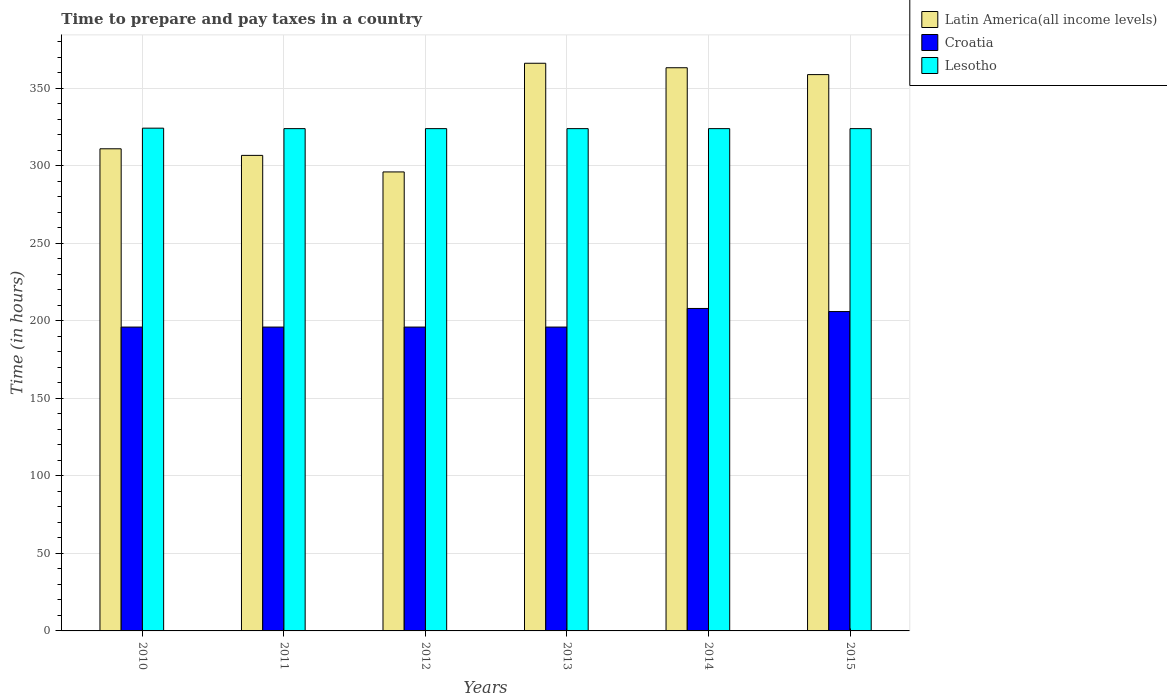How many different coloured bars are there?
Give a very brief answer. 3. How many groups of bars are there?
Offer a terse response. 6. Are the number of bars on each tick of the X-axis equal?
Keep it short and to the point. Yes. How many bars are there on the 4th tick from the right?
Offer a very short reply. 3. What is the label of the 3rd group of bars from the left?
Provide a short and direct response. 2012. In how many cases, is the number of bars for a given year not equal to the number of legend labels?
Offer a very short reply. 0. What is the number of hours required to prepare and pay taxes in Croatia in 2014?
Provide a succinct answer. 208. Across all years, what is the maximum number of hours required to prepare and pay taxes in Croatia?
Your answer should be very brief. 208. Across all years, what is the minimum number of hours required to prepare and pay taxes in Latin America(all income levels)?
Your answer should be compact. 296.06. In which year was the number of hours required to prepare and pay taxes in Latin America(all income levels) minimum?
Ensure brevity in your answer.  2012. What is the total number of hours required to prepare and pay taxes in Croatia in the graph?
Your response must be concise. 1198. What is the difference between the number of hours required to prepare and pay taxes in Lesotho in 2012 and that in 2015?
Your answer should be very brief. 0. What is the difference between the number of hours required to prepare and pay taxes in Latin America(all income levels) in 2010 and the number of hours required to prepare and pay taxes in Croatia in 2014?
Offer a very short reply. 103. What is the average number of hours required to prepare and pay taxes in Latin America(all income levels) per year?
Your answer should be compact. 333.68. In the year 2011, what is the difference between the number of hours required to prepare and pay taxes in Latin America(all income levels) and number of hours required to prepare and pay taxes in Lesotho?
Your response must be concise. -17.26. In how many years, is the number of hours required to prepare and pay taxes in Croatia greater than 60 hours?
Make the answer very short. 6. What is the ratio of the number of hours required to prepare and pay taxes in Lesotho in 2010 to that in 2015?
Give a very brief answer. 1. Is the number of hours required to prepare and pay taxes in Latin America(all income levels) in 2012 less than that in 2014?
Offer a very short reply. Yes. Is the difference between the number of hours required to prepare and pay taxes in Latin America(all income levels) in 2012 and 2013 greater than the difference between the number of hours required to prepare and pay taxes in Lesotho in 2012 and 2013?
Provide a short and direct response. No. What is the difference between the highest and the second highest number of hours required to prepare and pay taxes in Latin America(all income levels)?
Give a very brief answer. 2.89. What is the difference between the highest and the lowest number of hours required to prepare and pay taxes in Lesotho?
Offer a terse response. 0.3. In how many years, is the number of hours required to prepare and pay taxes in Lesotho greater than the average number of hours required to prepare and pay taxes in Lesotho taken over all years?
Your answer should be very brief. 1. What does the 2nd bar from the left in 2014 represents?
Your response must be concise. Croatia. What does the 3rd bar from the right in 2011 represents?
Your answer should be compact. Latin America(all income levels). How many bars are there?
Offer a very short reply. 18. Are all the bars in the graph horizontal?
Ensure brevity in your answer.  No. What is the difference between two consecutive major ticks on the Y-axis?
Your response must be concise. 50. Does the graph contain any zero values?
Provide a short and direct response. No. Does the graph contain grids?
Make the answer very short. Yes. Where does the legend appear in the graph?
Provide a short and direct response. Top right. How many legend labels are there?
Make the answer very short. 3. What is the title of the graph?
Your answer should be compact. Time to prepare and pay taxes in a country. What is the label or title of the Y-axis?
Offer a terse response. Time (in hours). What is the Time (in hours) in Latin America(all income levels) in 2010?
Provide a succinct answer. 311. What is the Time (in hours) of Croatia in 2010?
Your answer should be compact. 196. What is the Time (in hours) in Lesotho in 2010?
Provide a succinct answer. 324.3. What is the Time (in hours) of Latin America(all income levels) in 2011?
Provide a succinct answer. 306.74. What is the Time (in hours) of Croatia in 2011?
Make the answer very short. 196. What is the Time (in hours) in Lesotho in 2011?
Your answer should be compact. 324. What is the Time (in hours) in Latin America(all income levels) in 2012?
Make the answer very short. 296.06. What is the Time (in hours) in Croatia in 2012?
Provide a short and direct response. 196. What is the Time (in hours) of Lesotho in 2012?
Make the answer very short. 324. What is the Time (in hours) in Latin America(all income levels) in 2013?
Provide a short and direct response. 366.17. What is the Time (in hours) in Croatia in 2013?
Make the answer very short. 196. What is the Time (in hours) in Lesotho in 2013?
Provide a short and direct response. 324. What is the Time (in hours) of Latin America(all income levels) in 2014?
Offer a terse response. 363.27. What is the Time (in hours) of Croatia in 2014?
Provide a short and direct response. 208. What is the Time (in hours) of Lesotho in 2014?
Provide a short and direct response. 324. What is the Time (in hours) in Latin America(all income levels) in 2015?
Offer a very short reply. 358.85. What is the Time (in hours) of Croatia in 2015?
Provide a short and direct response. 206. What is the Time (in hours) in Lesotho in 2015?
Make the answer very short. 324. Across all years, what is the maximum Time (in hours) of Latin America(all income levels)?
Offer a very short reply. 366.17. Across all years, what is the maximum Time (in hours) in Croatia?
Make the answer very short. 208. Across all years, what is the maximum Time (in hours) in Lesotho?
Your response must be concise. 324.3. Across all years, what is the minimum Time (in hours) in Latin America(all income levels)?
Give a very brief answer. 296.06. Across all years, what is the minimum Time (in hours) of Croatia?
Offer a terse response. 196. Across all years, what is the minimum Time (in hours) of Lesotho?
Ensure brevity in your answer.  324. What is the total Time (in hours) in Latin America(all income levels) in the graph?
Ensure brevity in your answer.  2002.09. What is the total Time (in hours) of Croatia in the graph?
Your answer should be compact. 1198. What is the total Time (in hours) of Lesotho in the graph?
Offer a very short reply. 1944.3. What is the difference between the Time (in hours) of Latin America(all income levels) in 2010 and that in 2011?
Offer a terse response. 4.26. What is the difference between the Time (in hours) in Croatia in 2010 and that in 2011?
Give a very brief answer. 0. What is the difference between the Time (in hours) in Lesotho in 2010 and that in 2011?
Ensure brevity in your answer.  0.3. What is the difference between the Time (in hours) in Latin America(all income levels) in 2010 and that in 2012?
Keep it short and to the point. 14.94. What is the difference between the Time (in hours) of Croatia in 2010 and that in 2012?
Provide a short and direct response. 0. What is the difference between the Time (in hours) of Latin America(all income levels) in 2010 and that in 2013?
Give a very brief answer. -55.17. What is the difference between the Time (in hours) of Croatia in 2010 and that in 2013?
Ensure brevity in your answer.  0. What is the difference between the Time (in hours) of Lesotho in 2010 and that in 2013?
Give a very brief answer. 0.3. What is the difference between the Time (in hours) of Latin America(all income levels) in 2010 and that in 2014?
Offer a terse response. -52.27. What is the difference between the Time (in hours) in Croatia in 2010 and that in 2014?
Give a very brief answer. -12. What is the difference between the Time (in hours) of Latin America(all income levels) in 2010 and that in 2015?
Ensure brevity in your answer.  -47.85. What is the difference between the Time (in hours) in Croatia in 2010 and that in 2015?
Provide a succinct answer. -10. What is the difference between the Time (in hours) in Lesotho in 2010 and that in 2015?
Keep it short and to the point. 0.3. What is the difference between the Time (in hours) of Latin America(all income levels) in 2011 and that in 2012?
Your answer should be compact. 10.68. What is the difference between the Time (in hours) of Lesotho in 2011 and that in 2012?
Provide a succinct answer. 0. What is the difference between the Time (in hours) of Latin America(all income levels) in 2011 and that in 2013?
Give a very brief answer. -59.42. What is the difference between the Time (in hours) of Croatia in 2011 and that in 2013?
Your answer should be compact. 0. What is the difference between the Time (in hours) in Lesotho in 2011 and that in 2013?
Keep it short and to the point. 0. What is the difference between the Time (in hours) in Latin America(all income levels) in 2011 and that in 2014?
Provide a succinct answer. -56.53. What is the difference between the Time (in hours) of Croatia in 2011 and that in 2014?
Make the answer very short. -12. What is the difference between the Time (in hours) of Latin America(all income levels) in 2011 and that in 2015?
Offer a very short reply. -52.11. What is the difference between the Time (in hours) of Croatia in 2011 and that in 2015?
Your response must be concise. -10. What is the difference between the Time (in hours) of Latin America(all income levels) in 2012 and that in 2013?
Provide a succinct answer. -70.1. What is the difference between the Time (in hours) in Croatia in 2012 and that in 2013?
Your answer should be very brief. 0. What is the difference between the Time (in hours) in Lesotho in 2012 and that in 2013?
Keep it short and to the point. 0. What is the difference between the Time (in hours) of Latin America(all income levels) in 2012 and that in 2014?
Make the answer very short. -67.21. What is the difference between the Time (in hours) of Croatia in 2012 and that in 2014?
Ensure brevity in your answer.  -12. What is the difference between the Time (in hours) in Lesotho in 2012 and that in 2014?
Your answer should be very brief. 0. What is the difference between the Time (in hours) in Latin America(all income levels) in 2012 and that in 2015?
Provide a succinct answer. -62.78. What is the difference between the Time (in hours) in Croatia in 2012 and that in 2015?
Provide a short and direct response. -10. What is the difference between the Time (in hours) of Latin America(all income levels) in 2013 and that in 2014?
Provide a succinct answer. 2.89. What is the difference between the Time (in hours) of Lesotho in 2013 and that in 2014?
Provide a short and direct response. 0. What is the difference between the Time (in hours) of Latin America(all income levels) in 2013 and that in 2015?
Your answer should be very brief. 7.32. What is the difference between the Time (in hours) in Lesotho in 2013 and that in 2015?
Ensure brevity in your answer.  0. What is the difference between the Time (in hours) in Latin America(all income levels) in 2014 and that in 2015?
Your response must be concise. 4.42. What is the difference between the Time (in hours) of Croatia in 2014 and that in 2015?
Provide a short and direct response. 2. What is the difference between the Time (in hours) in Lesotho in 2014 and that in 2015?
Your answer should be compact. 0. What is the difference between the Time (in hours) of Latin America(all income levels) in 2010 and the Time (in hours) of Croatia in 2011?
Give a very brief answer. 115. What is the difference between the Time (in hours) of Croatia in 2010 and the Time (in hours) of Lesotho in 2011?
Offer a terse response. -128. What is the difference between the Time (in hours) of Latin America(all income levels) in 2010 and the Time (in hours) of Croatia in 2012?
Provide a short and direct response. 115. What is the difference between the Time (in hours) of Croatia in 2010 and the Time (in hours) of Lesotho in 2012?
Make the answer very short. -128. What is the difference between the Time (in hours) of Latin America(all income levels) in 2010 and the Time (in hours) of Croatia in 2013?
Offer a terse response. 115. What is the difference between the Time (in hours) in Croatia in 2010 and the Time (in hours) in Lesotho in 2013?
Provide a short and direct response. -128. What is the difference between the Time (in hours) in Latin America(all income levels) in 2010 and the Time (in hours) in Croatia in 2014?
Make the answer very short. 103. What is the difference between the Time (in hours) in Croatia in 2010 and the Time (in hours) in Lesotho in 2014?
Keep it short and to the point. -128. What is the difference between the Time (in hours) in Latin America(all income levels) in 2010 and the Time (in hours) in Croatia in 2015?
Keep it short and to the point. 105. What is the difference between the Time (in hours) in Latin America(all income levels) in 2010 and the Time (in hours) in Lesotho in 2015?
Provide a short and direct response. -13. What is the difference between the Time (in hours) in Croatia in 2010 and the Time (in hours) in Lesotho in 2015?
Keep it short and to the point. -128. What is the difference between the Time (in hours) of Latin America(all income levels) in 2011 and the Time (in hours) of Croatia in 2012?
Keep it short and to the point. 110.74. What is the difference between the Time (in hours) of Latin America(all income levels) in 2011 and the Time (in hours) of Lesotho in 2012?
Offer a very short reply. -17.26. What is the difference between the Time (in hours) in Croatia in 2011 and the Time (in hours) in Lesotho in 2012?
Your answer should be very brief. -128. What is the difference between the Time (in hours) in Latin America(all income levels) in 2011 and the Time (in hours) in Croatia in 2013?
Offer a very short reply. 110.74. What is the difference between the Time (in hours) of Latin America(all income levels) in 2011 and the Time (in hours) of Lesotho in 2013?
Your answer should be compact. -17.26. What is the difference between the Time (in hours) of Croatia in 2011 and the Time (in hours) of Lesotho in 2013?
Your answer should be very brief. -128. What is the difference between the Time (in hours) in Latin America(all income levels) in 2011 and the Time (in hours) in Croatia in 2014?
Provide a succinct answer. 98.74. What is the difference between the Time (in hours) of Latin America(all income levels) in 2011 and the Time (in hours) of Lesotho in 2014?
Your answer should be very brief. -17.26. What is the difference between the Time (in hours) of Croatia in 2011 and the Time (in hours) of Lesotho in 2014?
Ensure brevity in your answer.  -128. What is the difference between the Time (in hours) in Latin America(all income levels) in 2011 and the Time (in hours) in Croatia in 2015?
Make the answer very short. 100.74. What is the difference between the Time (in hours) of Latin America(all income levels) in 2011 and the Time (in hours) of Lesotho in 2015?
Provide a short and direct response. -17.26. What is the difference between the Time (in hours) of Croatia in 2011 and the Time (in hours) of Lesotho in 2015?
Provide a short and direct response. -128. What is the difference between the Time (in hours) of Latin America(all income levels) in 2012 and the Time (in hours) of Croatia in 2013?
Offer a terse response. 100.06. What is the difference between the Time (in hours) of Latin America(all income levels) in 2012 and the Time (in hours) of Lesotho in 2013?
Provide a succinct answer. -27.94. What is the difference between the Time (in hours) of Croatia in 2012 and the Time (in hours) of Lesotho in 2013?
Offer a very short reply. -128. What is the difference between the Time (in hours) of Latin America(all income levels) in 2012 and the Time (in hours) of Croatia in 2014?
Your response must be concise. 88.06. What is the difference between the Time (in hours) in Latin America(all income levels) in 2012 and the Time (in hours) in Lesotho in 2014?
Your answer should be compact. -27.94. What is the difference between the Time (in hours) of Croatia in 2012 and the Time (in hours) of Lesotho in 2014?
Ensure brevity in your answer.  -128. What is the difference between the Time (in hours) in Latin America(all income levels) in 2012 and the Time (in hours) in Croatia in 2015?
Give a very brief answer. 90.06. What is the difference between the Time (in hours) of Latin America(all income levels) in 2012 and the Time (in hours) of Lesotho in 2015?
Offer a very short reply. -27.94. What is the difference between the Time (in hours) of Croatia in 2012 and the Time (in hours) of Lesotho in 2015?
Offer a very short reply. -128. What is the difference between the Time (in hours) in Latin America(all income levels) in 2013 and the Time (in hours) in Croatia in 2014?
Keep it short and to the point. 158.17. What is the difference between the Time (in hours) in Latin America(all income levels) in 2013 and the Time (in hours) in Lesotho in 2014?
Your response must be concise. 42.17. What is the difference between the Time (in hours) of Croatia in 2013 and the Time (in hours) of Lesotho in 2014?
Provide a succinct answer. -128. What is the difference between the Time (in hours) of Latin America(all income levels) in 2013 and the Time (in hours) of Croatia in 2015?
Your response must be concise. 160.17. What is the difference between the Time (in hours) of Latin America(all income levels) in 2013 and the Time (in hours) of Lesotho in 2015?
Ensure brevity in your answer.  42.17. What is the difference between the Time (in hours) of Croatia in 2013 and the Time (in hours) of Lesotho in 2015?
Provide a succinct answer. -128. What is the difference between the Time (in hours) of Latin America(all income levels) in 2014 and the Time (in hours) of Croatia in 2015?
Offer a terse response. 157.27. What is the difference between the Time (in hours) of Latin America(all income levels) in 2014 and the Time (in hours) of Lesotho in 2015?
Give a very brief answer. 39.27. What is the difference between the Time (in hours) in Croatia in 2014 and the Time (in hours) in Lesotho in 2015?
Offer a terse response. -116. What is the average Time (in hours) of Latin America(all income levels) per year?
Your answer should be very brief. 333.68. What is the average Time (in hours) of Croatia per year?
Your answer should be very brief. 199.67. What is the average Time (in hours) in Lesotho per year?
Give a very brief answer. 324.05. In the year 2010, what is the difference between the Time (in hours) of Latin America(all income levels) and Time (in hours) of Croatia?
Ensure brevity in your answer.  115. In the year 2010, what is the difference between the Time (in hours) in Croatia and Time (in hours) in Lesotho?
Provide a short and direct response. -128.3. In the year 2011, what is the difference between the Time (in hours) in Latin America(all income levels) and Time (in hours) in Croatia?
Keep it short and to the point. 110.74. In the year 2011, what is the difference between the Time (in hours) of Latin America(all income levels) and Time (in hours) of Lesotho?
Give a very brief answer. -17.26. In the year 2011, what is the difference between the Time (in hours) in Croatia and Time (in hours) in Lesotho?
Offer a very short reply. -128. In the year 2012, what is the difference between the Time (in hours) in Latin America(all income levels) and Time (in hours) in Croatia?
Provide a short and direct response. 100.06. In the year 2012, what is the difference between the Time (in hours) in Latin America(all income levels) and Time (in hours) in Lesotho?
Provide a short and direct response. -27.94. In the year 2012, what is the difference between the Time (in hours) of Croatia and Time (in hours) of Lesotho?
Your response must be concise. -128. In the year 2013, what is the difference between the Time (in hours) of Latin America(all income levels) and Time (in hours) of Croatia?
Your answer should be very brief. 170.17. In the year 2013, what is the difference between the Time (in hours) in Latin America(all income levels) and Time (in hours) in Lesotho?
Your answer should be compact. 42.17. In the year 2013, what is the difference between the Time (in hours) in Croatia and Time (in hours) in Lesotho?
Provide a succinct answer. -128. In the year 2014, what is the difference between the Time (in hours) of Latin America(all income levels) and Time (in hours) of Croatia?
Provide a succinct answer. 155.27. In the year 2014, what is the difference between the Time (in hours) of Latin America(all income levels) and Time (in hours) of Lesotho?
Your answer should be compact. 39.27. In the year 2014, what is the difference between the Time (in hours) in Croatia and Time (in hours) in Lesotho?
Your response must be concise. -116. In the year 2015, what is the difference between the Time (in hours) in Latin America(all income levels) and Time (in hours) in Croatia?
Keep it short and to the point. 152.85. In the year 2015, what is the difference between the Time (in hours) of Latin America(all income levels) and Time (in hours) of Lesotho?
Make the answer very short. 34.85. In the year 2015, what is the difference between the Time (in hours) in Croatia and Time (in hours) in Lesotho?
Your answer should be very brief. -118. What is the ratio of the Time (in hours) in Latin America(all income levels) in 2010 to that in 2011?
Offer a very short reply. 1.01. What is the ratio of the Time (in hours) of Latin America(all income levels) in 2010 to that in 2012?
Make the answer very short. 1.05. What is the ratio of the Time (in hours) in Latin America(all income levels) in 2010 to that in 2013?
Provide a short and direct response. 0.85. What is the ratio of the Time (in hours) in Lesotho in 2010 to that in 2013?
Offer a terse response. 1. What is the ratio of the Time (in hours) of Latin America(all income levels) in 2010 to that in 2014?
Provide a succinct answer. 0.86. What is the ratio of the Time (in hours) in Croatia in 2010 to that in 2014?
Your answer should be compact. 0.94. What is the ratio of the Time (in hours) of Lesotho in 2010 to that in 2014?
Give a very brief answer. 1. What is the ratio of the Time (in hours) of Latin America(all income levels) in 2010 to that in 2015?
Offer a very short reply. 0.87. What is the ratio of the Time (in hours) of Croatia in 2010 to that in 2015?
Keep it short and to the point. 0.95. What is the ratio of the Time (in hours) of Lesotho in 2010 to that in 2015?
Your answer should be compact. 1. What is the ratio of the Time (in hours) of Latin America(all income levels) in 2011 to that in 2012?
Keep it short and to the point. 1.04. What is the ratio of the Time (in hours) in Lesotho in 2011 to that in 2012?
Your response must be concise. 1. What is the ratio of the Time (in hours) of Latin America(all income levels) in 2011 to that in 2013?
Give a very brief answer. 0.84. What is the ratio of the Time (in hours) of Croatia in 2011 to that in 2013?
Your answer should be very brief. 1. What is the ratio of the Time (in hours) in Lesotho in 2011 to that in 2013?
Offer a very short reply. 1. What is the ratio of the Time (in hours) in Latin America(all income levels) in 2011 to that in 2014?
Offer a very short reply. 0.84. What is the ratio of the Time (in hours) of Croatia in 2011 to that in 2014?
Offer a very short reply. 0.94. What is the ratio of the Time (in hours) in Lesotho in 2011 to that in 2014?
Your answer should be very brief. 1. What is the ratio of the Time (in hours) in Latin America(all income levels) in 2011 to that in 2015?
Your response must be concise. 0.85. What is the ratio of the Time (in hours) of Croatia in 2011 to that in 2015?
Make the answer very short. 0.95. What is the ratio of the Time (in hours) in Latin America(all income levels) in 2012 to that in 2013?
Make the answer very short. 0.81. What is the ratio of the Time (in hours) in Latin America(all income levels) in 2012 to that in 2014?
Ensure brevity in your answer.  0.81. What is the ratio of the Time (in hours) in Croatia in 2012 to that in 2014?
Offer a terse response. 0.94. What is the ratio of the Time (in hours) in Latin America(all income levels) in 2012 to that in 2015?
Make the answer very short. 0.82. What is the ratio of the Time (in hours) in Croatia in 2012 to that in 2015?
Give a very brief answer. 0.95. What is the ratio of the Time (in hours) in Lesotho in 2012 to that in 2015?
Offer a very short reply. 1. What is the ratio of the Time (in hours) in Latin America(all income levels) in 2013 to that in 2014?
Your response must be concise. 1.01. What is the ratio of the Time (in hours) of Croatia in 2013 to that in 2014?
Give a very brief answer. 0.94. What is the ratio of the Time (in hours) in Latin America(all income levels) in 2013 to that in 2015?
Your answer should be very brief. 1.02. What is the ratio of the Time (in hours) in Croatia in 2013 to that in 2015?
Offer a very short reply. 0.95. What is the ratio of the Time (in hours) in Latin America(all income levels) in 2014 to that in 2015?
Ensure brevity in your answer.  1.01. What is the ratio of the Time (in hours) in Croatia in 2014 to that in 2015?
Keep it short and to the point. 1.01. What is the ratio of the Time (in hours) of Lesotho in 2014 to that in 2015?
Offer a terse response. 1. What is the difference between the highest and the second highest Time (in hours) in Latin America(all income levels)?
Make the answer very short. 2.89. What is the difference between the highest and the second highest Time (in hours) in Croatia?
Keep it short and to the point. 2. What is the difference between the highest and the second highest Time (in hours) of Lesotho?
Keep it short and to the point. 0.3. What is the difference between the highest and the lowest Time (in hours) of Latin America(all income levels)?
Your response must be concise. 70.1. What is the difference between the highest and the lowest Time (in hours) of Lesotho?
Provide a short and direct response. 0.3. 